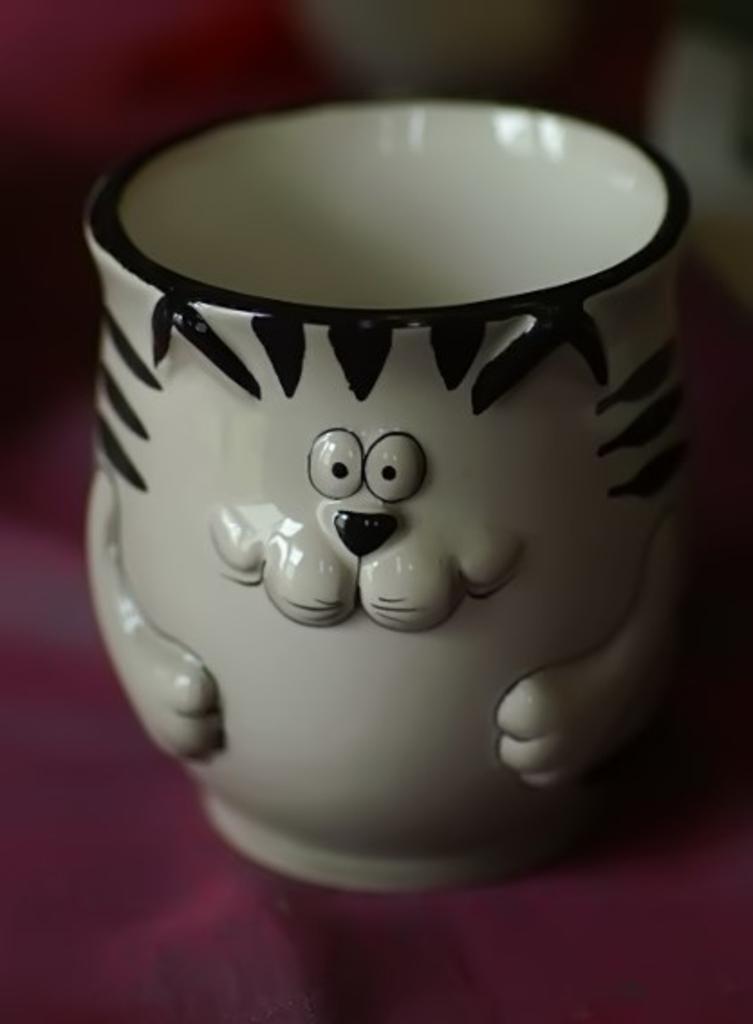In one or two sentences, can you explain what this image depicts? In this picture we can see a cup here, there is a blurry background here. 